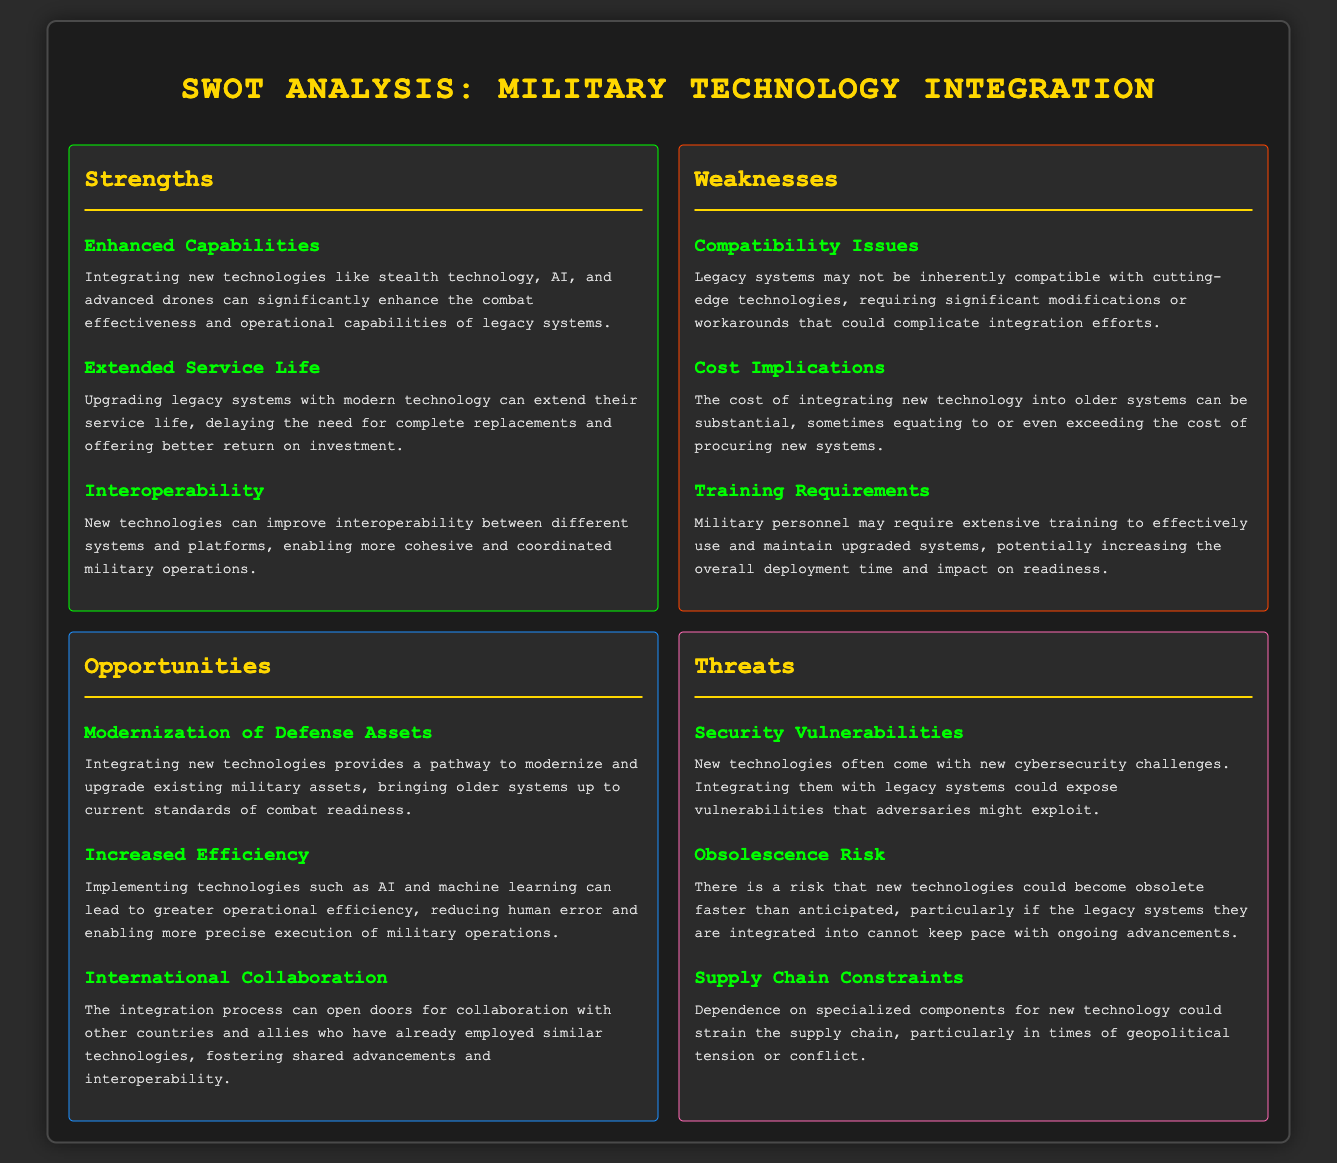What are the strengths of integrating new military technologies? The strengths are "Enhanced Capabilities", "Extended Service Life", and "Interoperability" described in the "Strengths" section.
Answer: Enhanced Capabilities, Extended Service Life, Interoperability What are the weaknesses associated with this integration? The weaknesses listed in the "Weaknesses" section include "Compatibility Issues", "Cost Implications", and "Training Requirements".
Answer: Compatibility Issues, Cost Implications, Training Requirements What opportunity is highlighted regarding international collaboration? The opportunity of "International Collaboration" is mentioned in the "Opportunities" section, emphasizing partnerships with other nations.
Answer: International Collaboration How many threats are stated in the document? The document identifies three threats in the "Threats" section.
Answer: Three What is the cost implication mentioned in the weaknesses? The weaknesses section discusses the substantial costs of integrating new technology into older systems, equating to or exceeding the cost of procuring new systems.
Answer: Substantial costs What technological advancements can enhance capabilities? The document lists "stealth technology, AI, and advanced drones" as advancements that enhance capabilities in the "Strengths" section.
Answer: Stealth technology, AI, advanced drones Which aspect can modernize defense assets? The "Modernization of Defense Assets" opportunity highlights integrating new technologies for upgrading existing military assets.
Answer: Modernization of Defense Assets What risks are associated with security in technology integration? The "Security Vulnerabilities" threat describes cybersecurity challenges and potential exploits by adversaries due to integration.
Answer: Security Vulnerabilities 